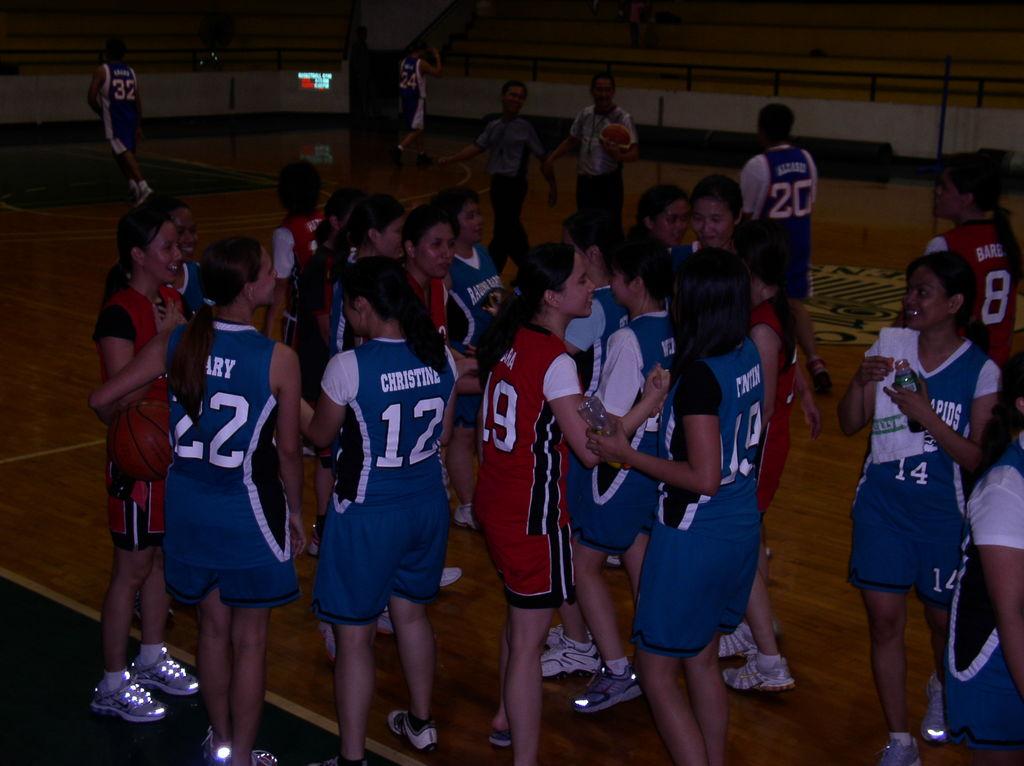What number is the player to the left of player 12?
Offer a very short reply. 22. 